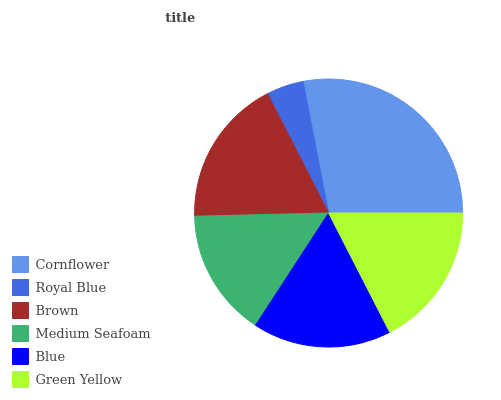Is Royal Blue the minimum?
Answer yes or no. Yes. Is Cornflower the maximum?
Answer yes or no. Yes. Is Brown the minimum?
Answer yes or no. No. Is Brown the maximum?
Answer yes or no. No. Is Brown greater than Royal Blue?
Answer yes or no. Yes. Is Royal Blue less than Brown?
Answer yes or no. Yes. Is Royal Blue greater than Brown?
Answer yes or no. No. Is Brown less than Royal Blue?
Answer yes or no. No. Is Green Yellow the high median?
Answer yes or no. Yes. Is Blue the low median?
Answer yes or no. Yes. Is Royal Blue the high median?
Answer yes or no. No. Is Cornflower the low median?
Answer yes or no. No. 